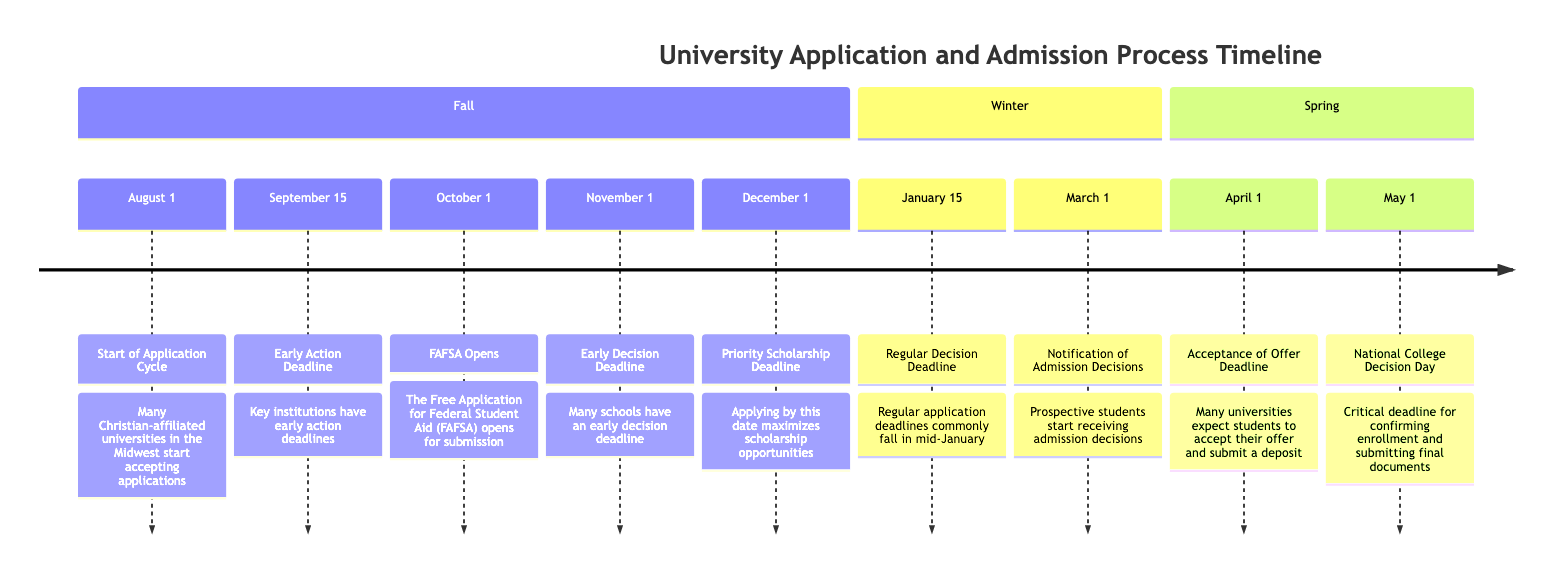What is the start date of the application cycle? The timeline shows "August 1" as the date when the application cycle begins. This is the first milestone in the timeline indicating when students can start submitting applications.
Answer: August 1 What is the regular decision deadline for universities? According to the timeline, the regular decision deadline is marked as "January 15". This indicates when students need to submit their regular applications for consideration.
Answer: January 15 Which milestone occurs after the Early Decision Deadline? The timeline lists the Early Decision Deadline on "November 1" and the next milestone is the "Priority Scholarship Deadline" on "December 1", showing the sequential nature of these milestones.
Answer: December 1 What is the date for National College Decision Day? The diagram clearly states that National College Decision Day is on "May 1", which is a critical deadline for students to confirm their enrollment at a university.
Answer: May 1 How many key milestones are listed in the Fall section? By reviewing the timeline in the Fall section, we can count six specific milestones: Start of Application Cycle, Early Action Deadline, FAFSA Opens, Early Decision Deadline, Priority Scholarship Deadline, and in total that equals six milestones.
Answer: 6 What milestone comes right before the Acceptance of Offer Deadline? The timeline indicates that March 1 is the date when prospective students receive notifications of admission decisions, which directly precedes the April 1 milestone for the Acceptance of Offer Deadline.
Answer: March 1 Which universities participate in the Early Action Deadline? The diagram references Taylor University and Bethel University as key institutions with an Early Action Deadline around mid-September, emphasizing these schools specifically for that milestone.
Answer: Taylor University and Bethel University What happens if a student misses the Priority Scholarship Deadline? The timeline suggests that if a student misses the December 1 Priority Scholarship Deadline, they will likely have fewer chances to receive scholarships based on the detail that applying by this date maximizes opportunities.
Answer: Fewer chances for scholarships Which date opens for financial aid submissions? The diagram indicates "October 1" as the date when the Free Application for Federal Student Aid (FAFSA) opens for submission, highlighting this date as important for financial aid applications.
Answer: October 1 